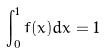<formula> <loc_0><loc_0><loc_500><loc_500>\int _ { 0 } ^ { 1 } f ( x ) d x = 1</formula> 